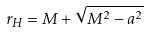Convert formula to latex. <formula><loc_0><loc_0><loc_500><loc_500>r _ { H } = M + \sqrt { M ^ { 2 } - a ^ { 2 } }</formula> 